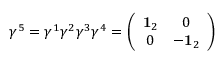Convert formula to latex. <formula><loc_0><loc_0><loc_500><loc_500>\gamma ^ { 5 } = \gamma ^ { 1 } \gamma ^ { 2 } \gamma ^ { 3 } \gamma ^ { 4 } = \left ( \begin{array} { c c } { { { 1 } _ { 2 } } } & { 0 } \\ { 0 } & { { - { 1 } _ { 2 } } } \end{array} \right )</formula> 